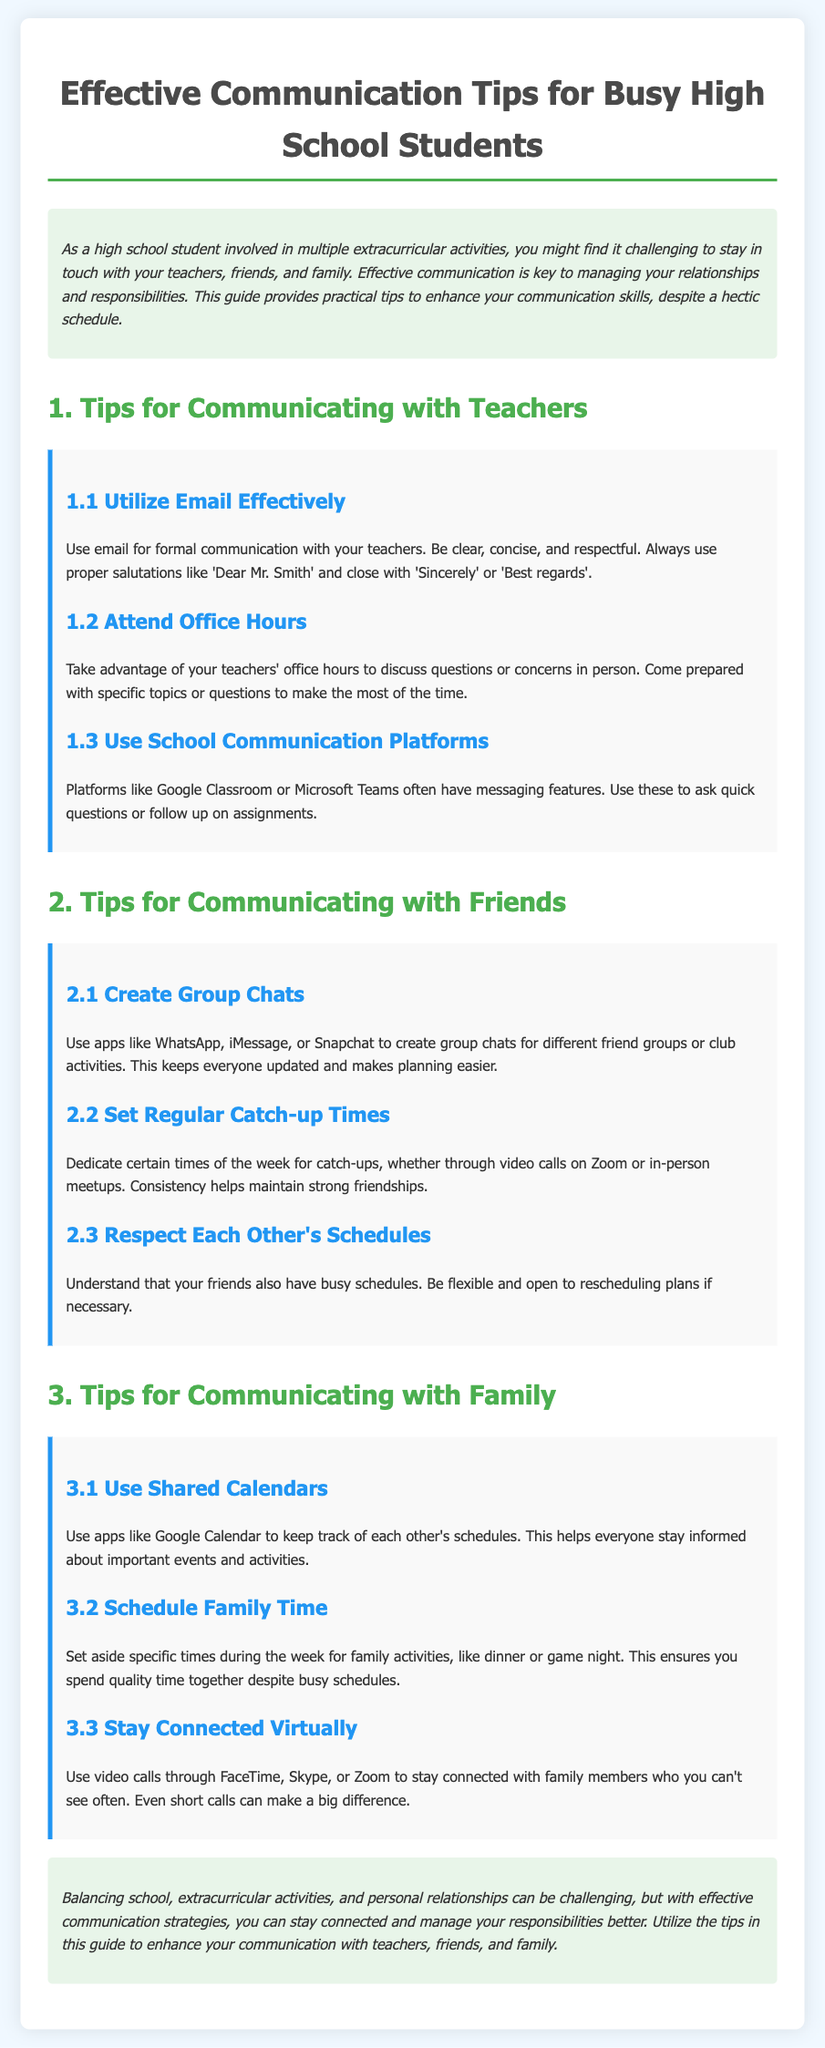what is the title of the document? The title of the document is prominently displayed at the top, providing an overview of its content.
Answer: Effective Communication Tips for Busy High School Students what are some examples of communication platforms mentioned? The document lists specific platforms that can be used for communication, particularly for students and teachers.
Answer: Google Classroom, Microsoft Teams how can students stay connected with family? The section on family communication provides strategies for staying in touch despite busy schedules.
Answer: Video calls what is one way to efficiently communicate with teachers? The document outlines practical tips for students, focusing on formal communication methods.
Answer: Use email how should students set up catch-up times with friends? The guide suggests establishing specific times to strengthen friendships amidst busy schedules.
Answer: Regular times what is highlighted as a benefit of using shared calendars? The document explains how shared calendars can improve family communication by organizing schedules.
Answer: Stay informed what type of communication tool is recommended for group planning? The document specifically mentions an app that facilitates group communication among friends.
Answer: Group chats what is the non-verbal method suggested for family time? The document emphasizes quality time spent with family through a traditional setting.
Answer: Game night how should students approach office hours? This tip encourages students to make the most of their teachers' availability for assistance.
Answer: Come prepared 